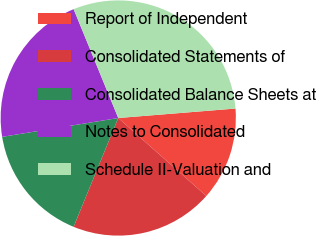<chart> <loc_0><loc_0><loc_500><loc_500><pie_chart><fcel>Report of Independent<fcel>Consolidated Statements of<fcel>Consolidated Balance Sheets at<fcel>Notes to Consolidated<fcel>Schedule II-Valuation and<nl><fcel>12.82%<fcel>19.66%<fcel>16.24%<fcel>21.37%<fcel>29.91%<nl></chart> 